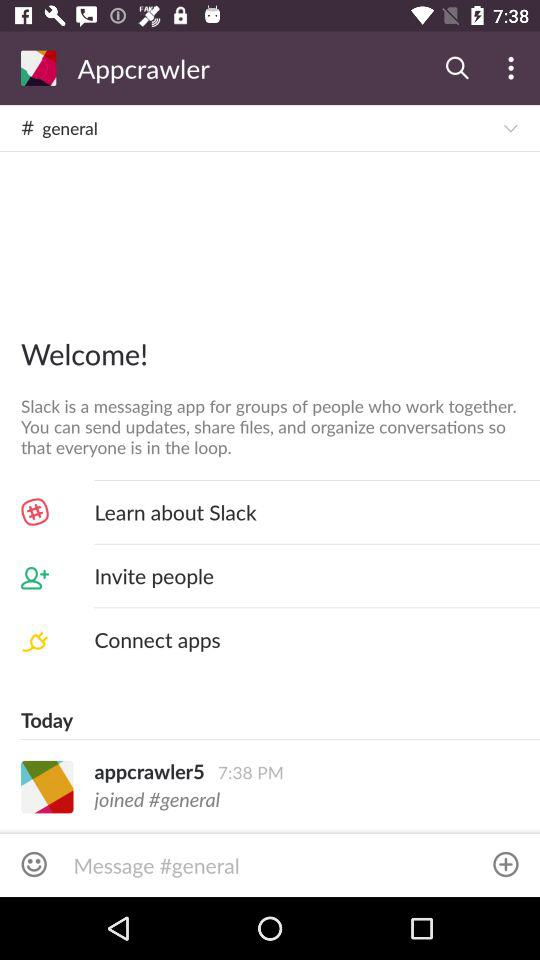What is the username? The username is "appcrawler5". 